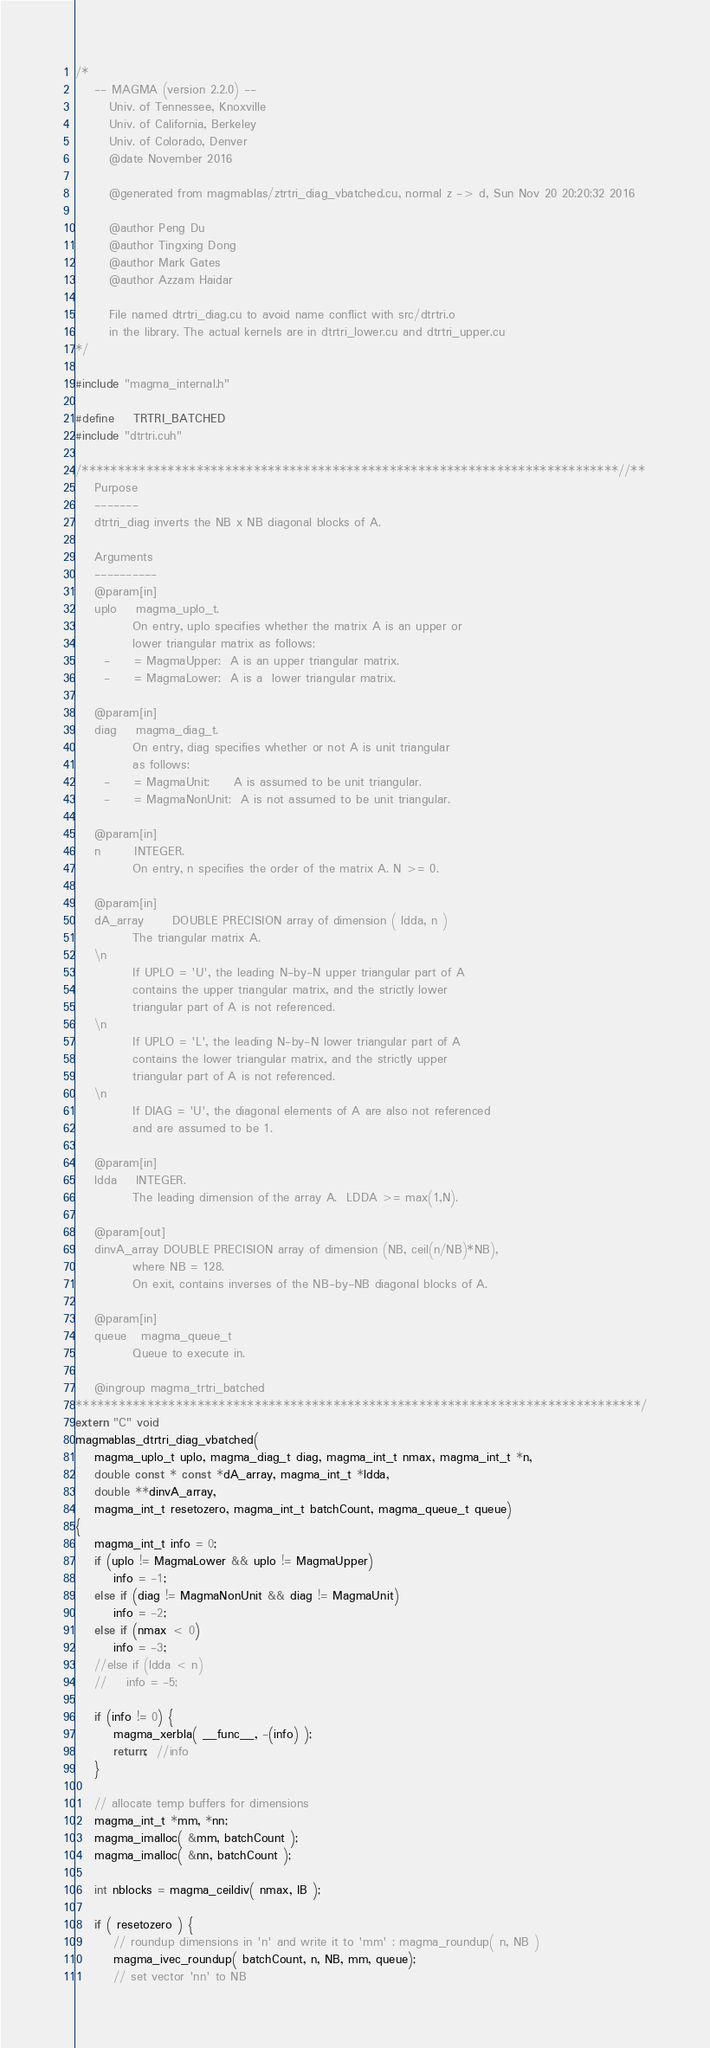Convert code to text. <code><loc_0><loc_0><loc_500><loc_500><_Cuda_>/*
    -- MAGMA (version 2.2.0) --
       Univ. of Tennessee, Knoxville
       Univ. of California, Berkeley
       Univ. of Colorado, Denver
       @date November 2016

       @generated from magmablas/ztrtri_diag_vbatched.cu, normal z -> d, Sun Nov 20 20:20:32 2016

       @author Peng Du
       @author Tingxing Dong
       @author Mark Gates
       @author Azzam Haidar
       
       File named dtrtri_diag.cu to avoid name conflict with src/dtrtri.o
       in the library. The actual kernels are in dtrtri_lower.cu and dtrtri_upper.cu
*/

#include "magma_internal.h"

#define    TRTRI_BATCHED
#include "dtrtri.cuh"

/***************************************************************************//**
    Purpose
    -------
    dtrtri_diag inverts the NB x NB diagonal blocks of A.

    Arguments
    ----------
    @param[in]
    uplo    magma_uplo_t.
            On entry, uplo specifies whether the matrix A is an upper or
            lower triangular matrix as follows:
      -     = MagmaUpper:  A is an upper triangular matrix.
      -     = MagmaLower:  A is a  lower triangular matrix.

    @param[in]
    diag    magma_diag_t.
            On entry, diag specifies whether or not A is unit triangular
            as follows:
      -     = MagmaUnit:     A is assumed to be unit triangular.
      -     = MagmaNonUnit:  A is not assumed to be unit triangular.

    @param[in]
    n       INTEGER.
            On entry, n specifies the order of the matrix A. N >= 0.

    @param[in]
    dA_array      DOUBLE PRECISION array of dimension ( ldda, n )
            The triangular matrix A.
    \n
            If UPLO = 'U', the leading N-by-N upper triangular part of A
            contains the upper triangular matrix, and the strictly lower
            triangular part of A is not referenced.
    \n
            If UPLO = 'L', the leading N-by-N lower triangular part of A
            contains the lower triangular matrix, and the strictly upper
            triangular part of A is not referenced.
    \n
            If DIAG = 'U', the diagonal elements of A are also not referenced
            and are assumed to be 1.

    @param[in]
    ldda    INTEGER.
            The leading dimension of the array A.  LDDA >= max(1,N).

    @param[out]
    dinvA_array DOUBLE PRECISION array of dimension (NB, ceil(n/NB)*NB),
            where NB = 128.
            On exit, contains inverses of the NB-by-NB diagonal blocks of A.

    @param[in]
    queue   magma_queue_t
            Queue to execute in.

    @ingroup magma_trtri_batched
*******************************************************************************/
extern "C" void
magmablas_dtrtri_diag_vbatched(
    magma_uplo_t uplo, magma_diag_t diag, magma_int_t nmax, magma_int_t *n,
    double const * const *dA_array, magma_int_t *ldda,
    double **dinvA_array, 
    magma_int_t resetozero, magma_int_t batchCount, magma_queue_t queue)
{
    magma_int_t info = 0;
    if (uplo != MagmaLower && uplo != MagmaUpper)
        info = -1;
    else if (diag != MagmaNonUnit && diag != MagmaUnit)
        info = -2;
    else if (nmax < 0)
        info = -3;
    //else if (ldda < n)
    //    info = -5;

    if (info != 0) {
        magma_xerbla( __func__, -(info) );
        return;  //info
    }
    
    // allocate temp buffers for dimensions
    magma_int_t *mm, *nn;
    magma_imalloc( &mm, batchCount );
    magma_imalloc( &nn, batchCount );
    
    int nblocks = magma_ceildiv( nmax, IB );

    if ( resetozero ) {
        // roundup dimensions in 'n' and write it to 'mm' : magma_roundup( n, NB ) 
        magma_ivec_roundup( batchCount, n, NB, mm, queue);
        // set vector 'nn' to NB</code> 